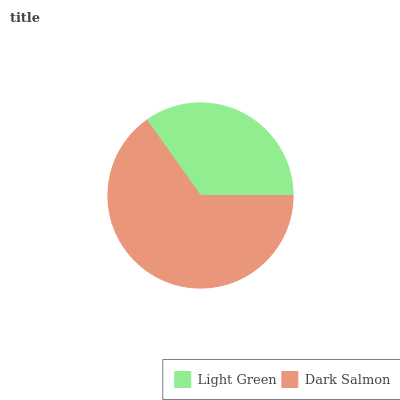Is Light Green the minimum?
Answer yes or no. Yes. Is Dark Salmon the maximum?
Answer yes or no. Yes. Is Dark Salmon the minimum?
Answer yes or no. No. Is Dark Salmon greater than Light Green?
Answer yes or no. Yes. Is Light Green less than Dark Salmon?
Answer yes or no. Yes. Is Light Green greater than Dark Salmon?
Answer yes or no. No. Is Dark Salmon less than Light Green?
Answer yes or no. No. Is Dark Salmon the high median?
Answer yes or no. Yes. Is Light Green the low median?
Answer yes or no. Yes. Is Light Green the high median?
Answer yes or no. No. Is Dark Salmon the low median?
Answer yes or no. No. 